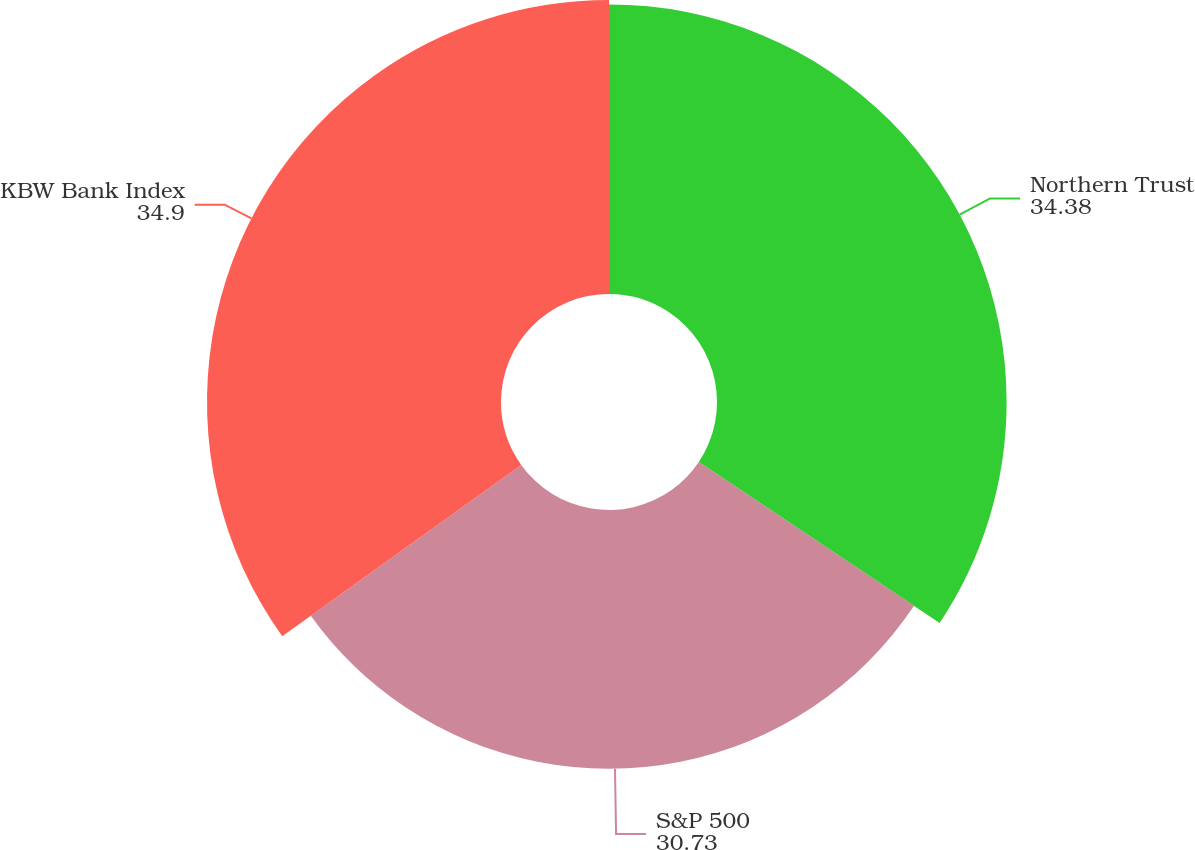<chart> <loc_0><loc_0><loc_500><loc_500><pie_chart><fcel>Northern Trust<fcel>S&P 500<fcel>KBW Bank Index<nl><fcel>34.38%<fcel>30.73%<fcel>34.9%<nl></chart> 